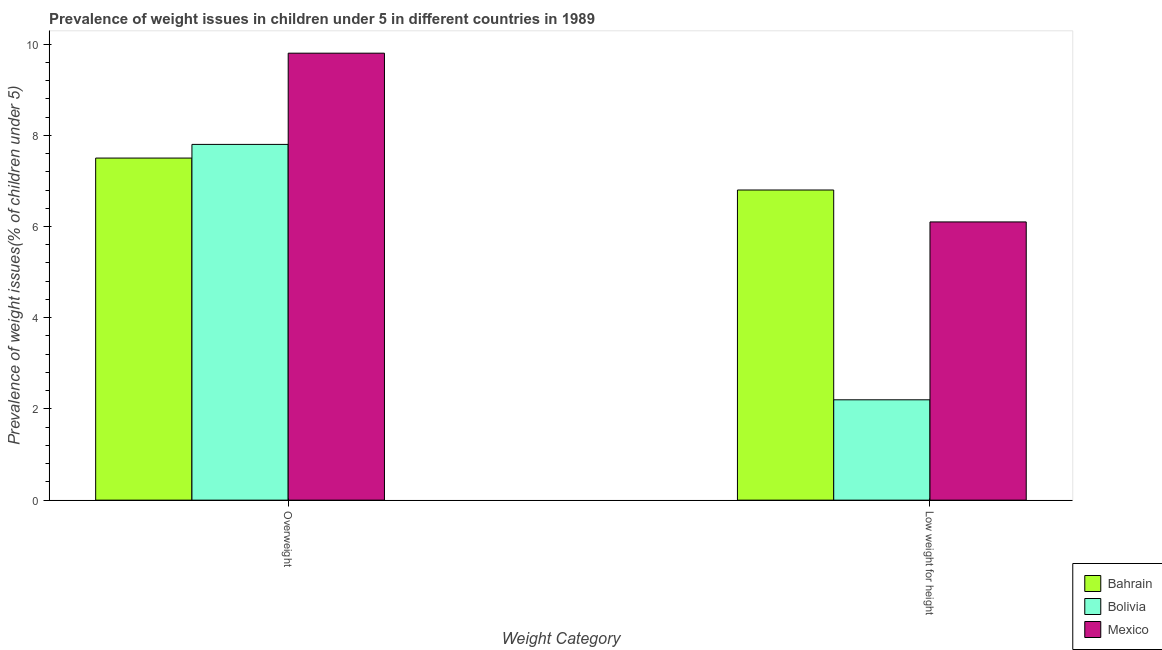How many groups of bars are there?
Your answer should be very brief. 2. Are the number of bars on each tick of the X-axis equal?
Your answer should be very brief. Yes. How many bars are there on the 1st tick from the left?
Offer a terse response. 3. What is the label of the 1st group of bars from the left?
Provide a short and direct response. Overweight. What is the percentage of underweight children in Bolivia?
Your answer should be very brief. 2.2. Across all countries, what is the maximum percentage of underweight children?
Provide a succinct answer. 6.8. Across all countries, what is the minimum percentage of underweight children?
Provide a succinct answer. 2.2. In which country was the percentage of underweight children minimum?
Provide a short and direct response. Bolivia. What is the total percentage of underweight children in the graph?
Your answer should be very brief. 15.1. What is the difference between the percentage of underweight children in Mexico and that in Bolivia?
Offer a terse response. 3.9. What is the difference between the percentage of overweight children in Mexico and the percentage of underweight children in Bolivia?
Keep it short and to the point. 7.6. What is the average percentage of overweight children per country?
Offer a terse response. 8.37. What is the difference between the percentage of overweight children and percentage of underweight children in Bahrain?
Provide a short and direct response. 0.7. In how many countries, is the percentage of overweight children greater than 0.4 %?
Offer a terse response. 3. What is the ratio of the percentage of overweight children in Mexico to that in Bolivia?
Ensure brevity in your answer.  1.26. In how many countries, is the percentage of underweight children greater than the average percentage of underweight children taken over all countries?
Give a very brief answer. 2. What does the 2nd bar from the right in Low weight for height represents?
Offer a very short reply. Bolivia. Are the values on the major ticks of Y-axis written in scientific E-notation?
Give a very brief answer. No. Does the graph contain grids?
Provide a succinct answer. No. Where does the legend appear in the graph?
Make the answer very short. Bottom right. How many legend labels are there?
Give a very brief answer. 3. How are the legend labels stacked?
Your response must be concise. Vertical. What is the title of the graph?
Your response must be concise. Prevalence of weight issues in children under 5 in different countries in 1989. What is the label or title of the X-axis?
Ensure brevity in your answer.  Weight Category. What is the label or title of the Y-axis?
Your answer should be compact. Prevalence of weight issues(% of children under 5). What is the Prevalence of weight issues(% of children under 5) in Bolivia in Overweight?
Keep it short and to the point. 7.8. What is the Prevalence of weight issues(% of children under 5) in Mexico in Overweight?
Your response must be concise. 9.8. What is the Prevalence of weight issues(% of children under 5) in Bahrain in Low weight for height?
Offer a terse response. 6.8. What is the Prevalence of weight issues(% of children under 5) in Bolivia in Low weight for height?
Keep it short and to the point. 2.2. What is the Prevalence of weight issues(% of children under 5) of Mexico in Low weight for height?
Your answer should be very brief. 6.1. Across all Weight Category, what is the maximum Prevalence of weight issues(% of children under 5) of Bolivia?
Keep it short and to the point. 7.8. Across all Weight Category, what is the maximum Prevalence of weight issues(% of children under 5) of Mexico?
Your answer should be compact. 9.8. Across all Weight Category, what is the minimum Prevalence of weight issues(% of children under 5) of Bahrain?
Keep it short and to the point. 6.8. Across all Weight Category, what is the minimum Prevalence of weight issues(% of children under 5) in Bolivia?
Give a very brief answer. 2.2. Across all Weight Category, what is the minimum Prevalence of weight issues(% of children under 5) in Mexico?
Provide a short and direct response. 6.1. What is the total Prevalence of weight issues(% of children under 5) of Bolivia in the graph?
Provide a succinct answer. 10. What is the difference between the Prevalence of weight issues(% of children under 5) of Bahrain in Overweight and that in Low weight for height?
Your answer should be compact. 0.7. What is the difference between the Prevalence of weight issues(% of children under 5) of Bolivia in Overweight and that in Low weight for height?
Ensure brevity in your answer.  5.6. What is the difference between the Prevalence of weight issues(% of children under 5) in Bahrain in Overweight and the Prevalence of weight issues(% of children under 5) in Bolivia in Low weight for height?
Give a very brief answer. 5.3. What is the difference between the Prevalence of weight issues(% of children under 5) in Bahrain in Overweight and the Prevalence of weight issues(% of children under 5) in Mexico in Low weight for height?
Your answer should be compact. 1.4. What is the difference between the Prevalence of weight issues(% of children under 5) in Bolivia in Overweight and the Prevalence of weight issues(% of children under 5) in Mexico in Low weight for height?
Your answer should be very brief. 1.7. What is the average Prevalence of weight issues(% of children under 5) of Bahrain per Weight Category?
Give a very brief answer. 7.15. What is the average Prevalence of weight issues(% of children under 5) in Bolivia per Weight Category?
Your answer should be compact. 5. What is the average Prevalence of weight issues(% of children under 5) in Mexico per Weight Category?
Your answer should be compact. 7.95. What is the difference between the Prevalence of weight issues(% of children under 5) of Bahrain and Prevalence of weight issues(% of children under 5) of Mexico in Overweight?
Give a very brief answer. -2.3. What is the difference between the Prevalence of weight issues(% of children under 5) of Bolivia and Prevalence of weight issues(% of children under 5) of Mexico in Overweight?
Give a very brief answer. -2. What is the difference between the Prevalence of weight issues(% of children under 5) of Bahrain and Prevalence of weight issues(% of children under 5) of Mexico in Low weight for height?
Make the answer very short. 0.7. What is the difference between the Prevalence of weight issues(% of children under 5) of Bolivia and Prevalence of weight issues(% of children under 5) of Mexico in Low weight for height?
Provide a short and direct response. -3.9. What is the ratio of the Prevalence of weight issues(% of children under 5) in Bahrain in Overweight to that in Low weight for height?
Your answer should be very brief. 1.1. What is the ratio of the Prevalence of weight issues(% of children under 5) of Bolivia in Overweight to that in Low weight for height?
Provide a short and direct response. 3.55. What is the ratio of the Prevalence of weight issues(% of children under 5) in Mexico in Overweight to that in Low weight for height?
Provide a succinct answer. 1.61. What is the difference between the highest and the second highest Prevalence of weight issues(% of children under 5) in Bahrain?
Your answer should be very brief. 0.7. What is the difference between the highest and the lowest Prevalence of weight issues(% of children under 5) of Bolivia?
Make the answer very short. 5.6. What is the difference between the highest and the lowest Prevalence of weight issues(% of children under 5) in Mexico?
Provide a succinct answer. 3.7. 